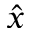Convert formula to latex. <formula><loc_0><loc_0><loc_500><loc_500>\hat { x }</formula> 